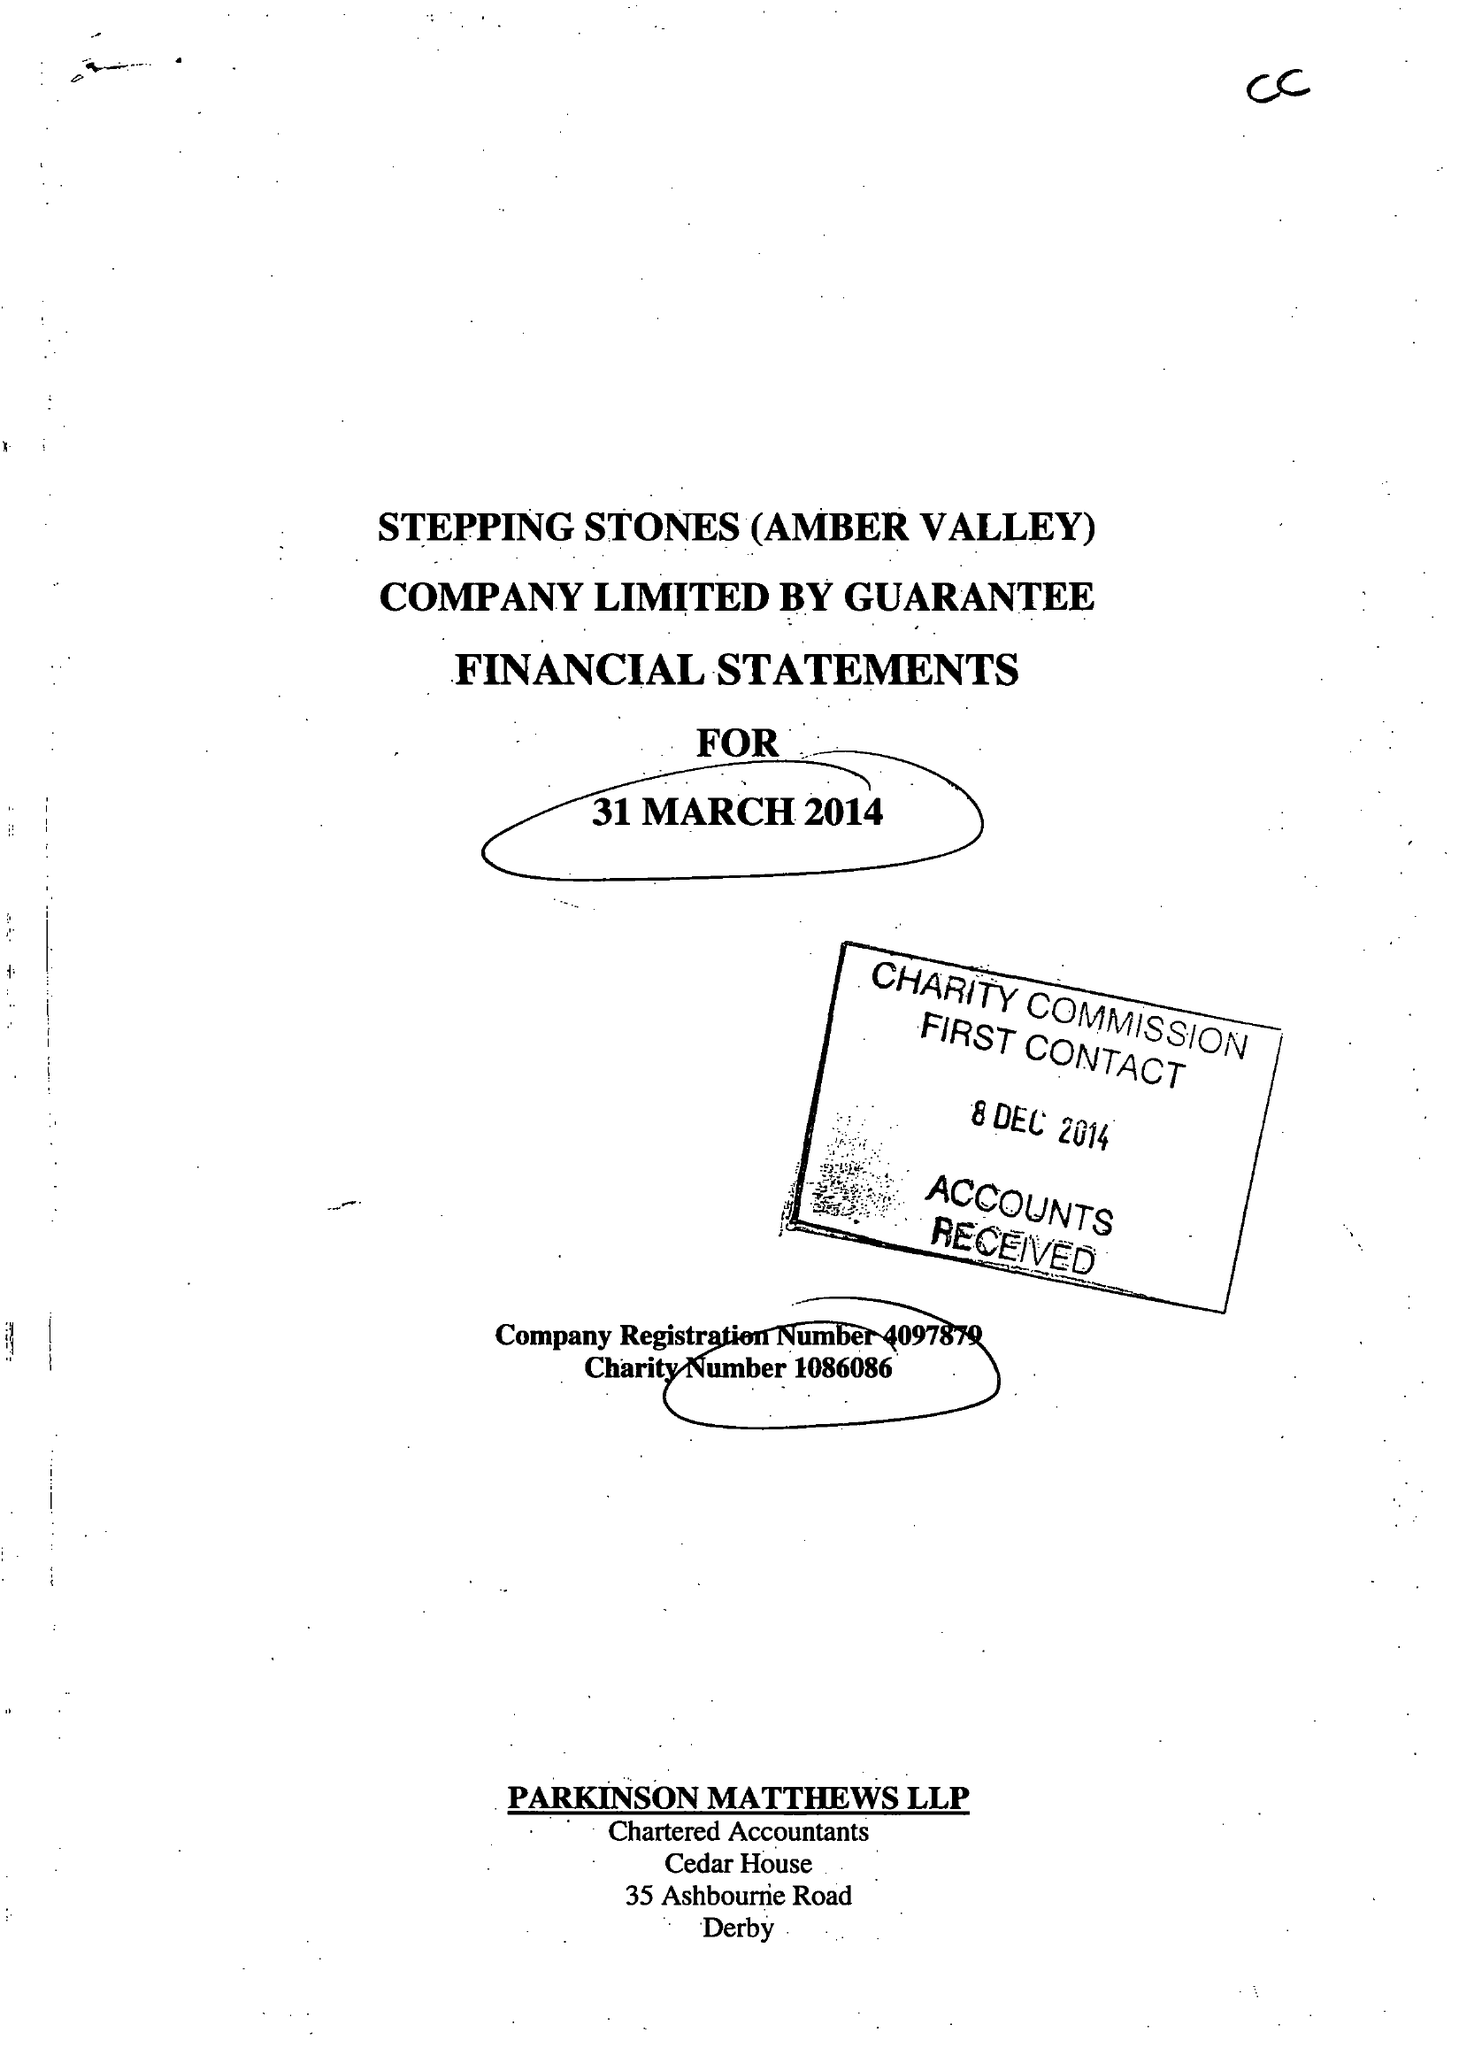What is the value for the charity_number?
Answer the question using a single word or phrase. 1086086 